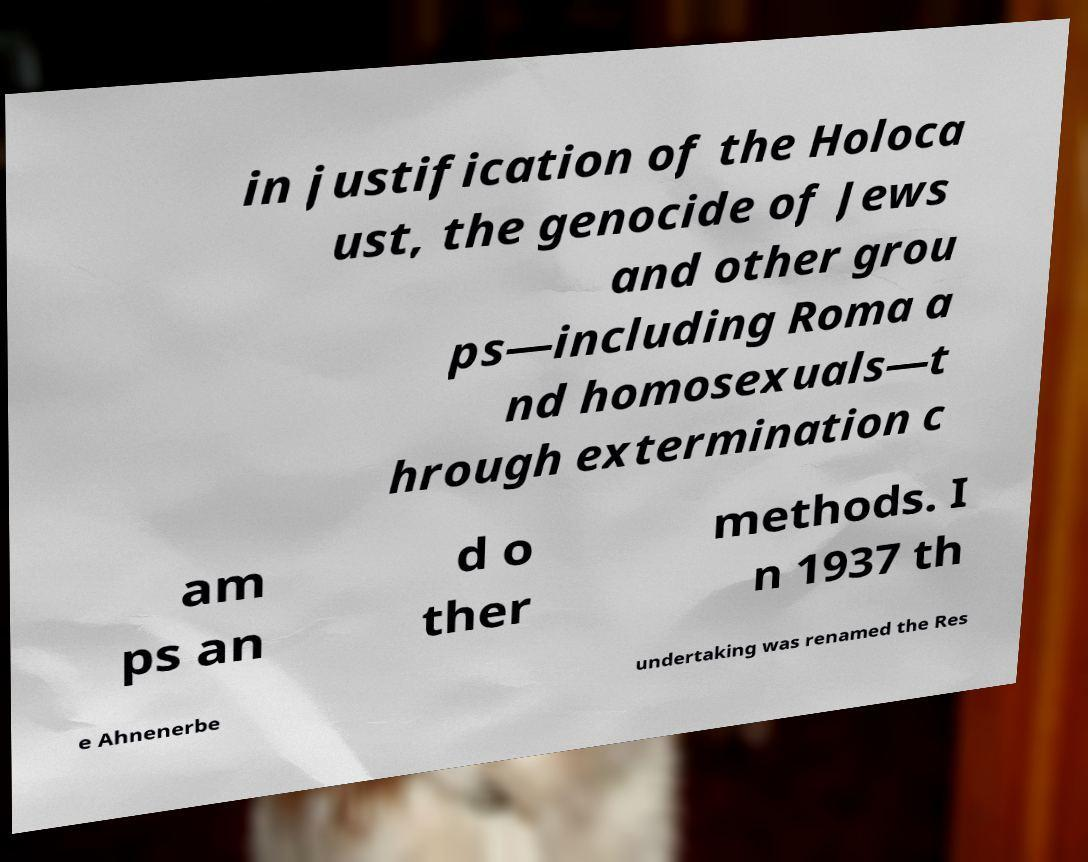Please identify and transcribe the text found in this image. in justification of the Holoca ust, the genocide of Jews and other grou ps—including Roma a nd homosexuals—t hrough extermination c am ps an d o ther methods. I n 1937 th e Ahnenerbe undertaking was renamed the Res 